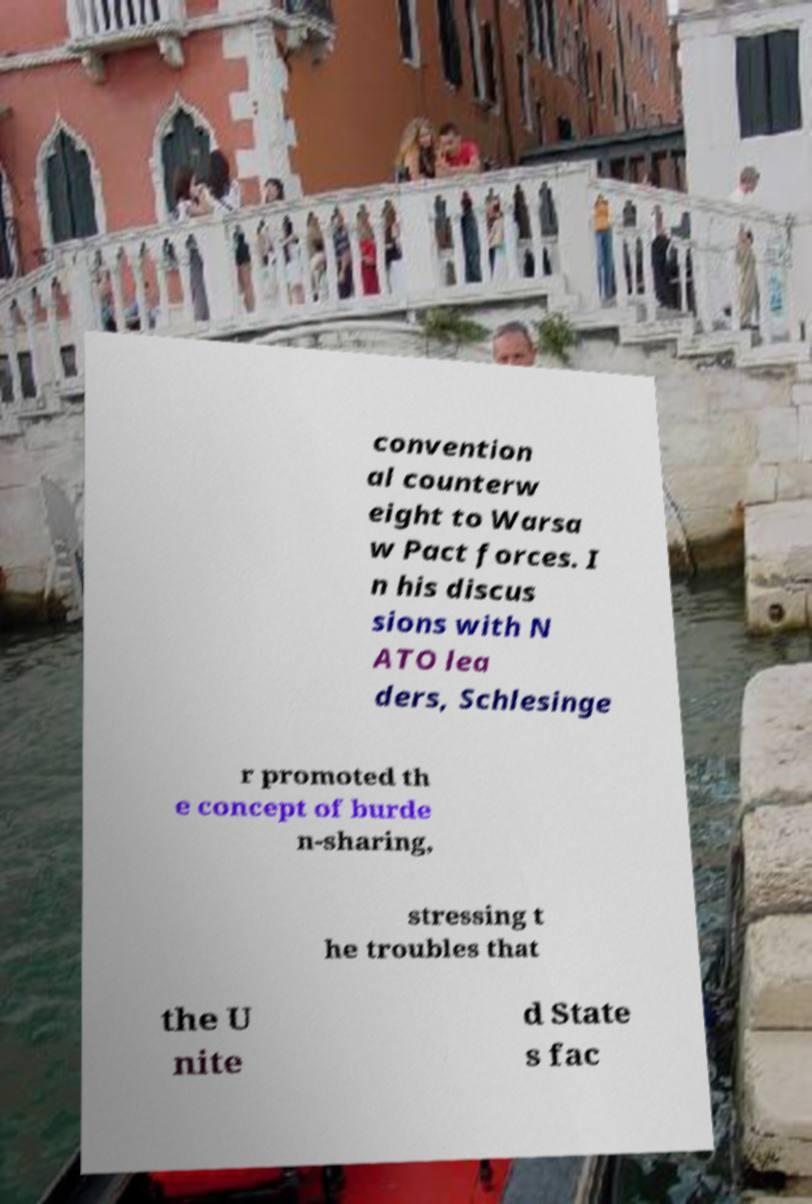What messages or text are displayed in this image? I need them in a readable, typed format. convention al counterw eight to Warsa w Pact forces. I n his discus sions with N ATO lea ders, Schlesinge r promoted th e concept of burde n-sharing, stressing t he troubles that the U nite d State s fac 